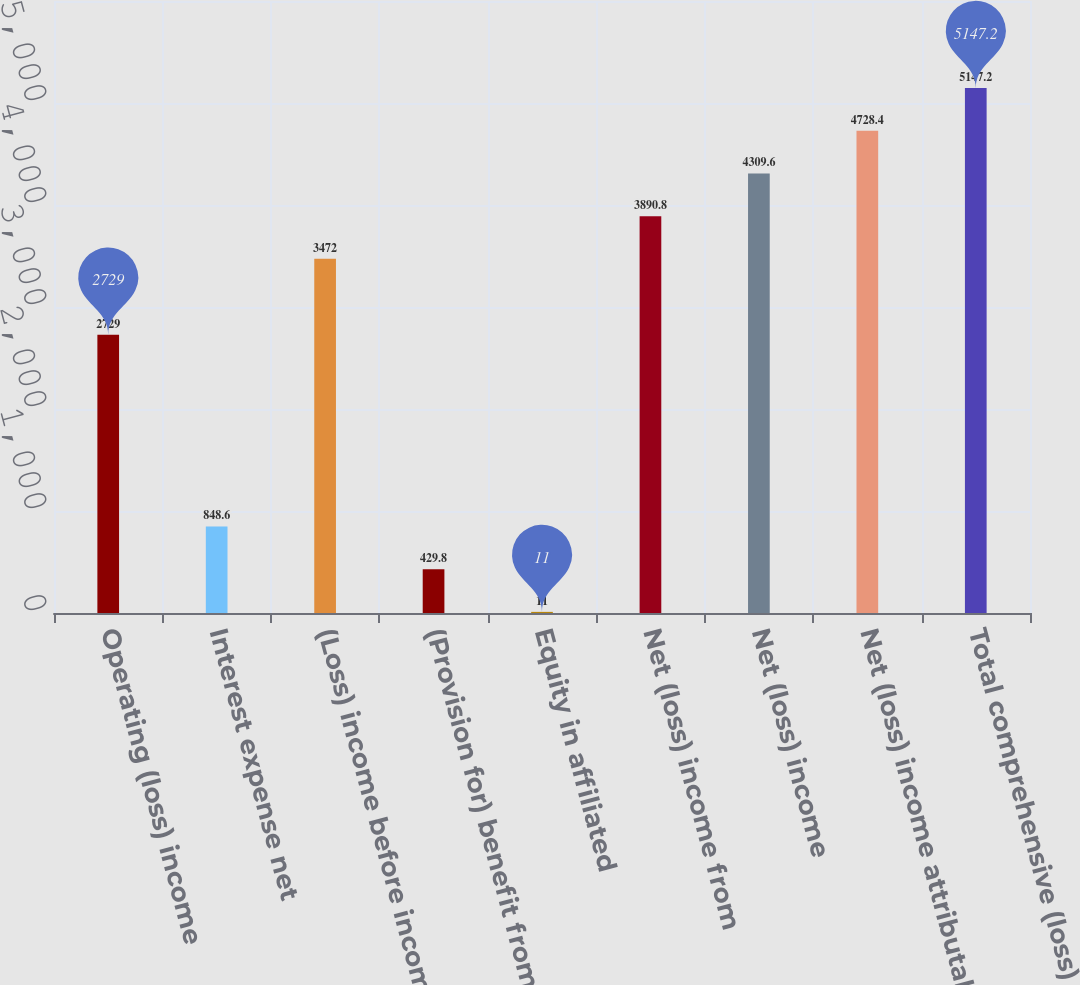Convert chart. <chart><loc_0><loc_0><loc_500><loc_500><bar_chart><fcel>Operating (loss) income<fcel>Interest expense net<fcel>(Loss) income before income<fcel>(Provision for) benefit from<fcel>Equity in affiliated<fcel>Net (loss) income from<fcel>Net (loss) income<fcel>Net (loss) income attributable<fcel>Total comprehensive (loss)<nl><fcel>2729<fcel>848.6<fcel>3472<fcel>429.8<fcel>11<fcel>3890.8<fcel>4309.6<fcel>4728.4<fcel>5147.2<nl></chart> 